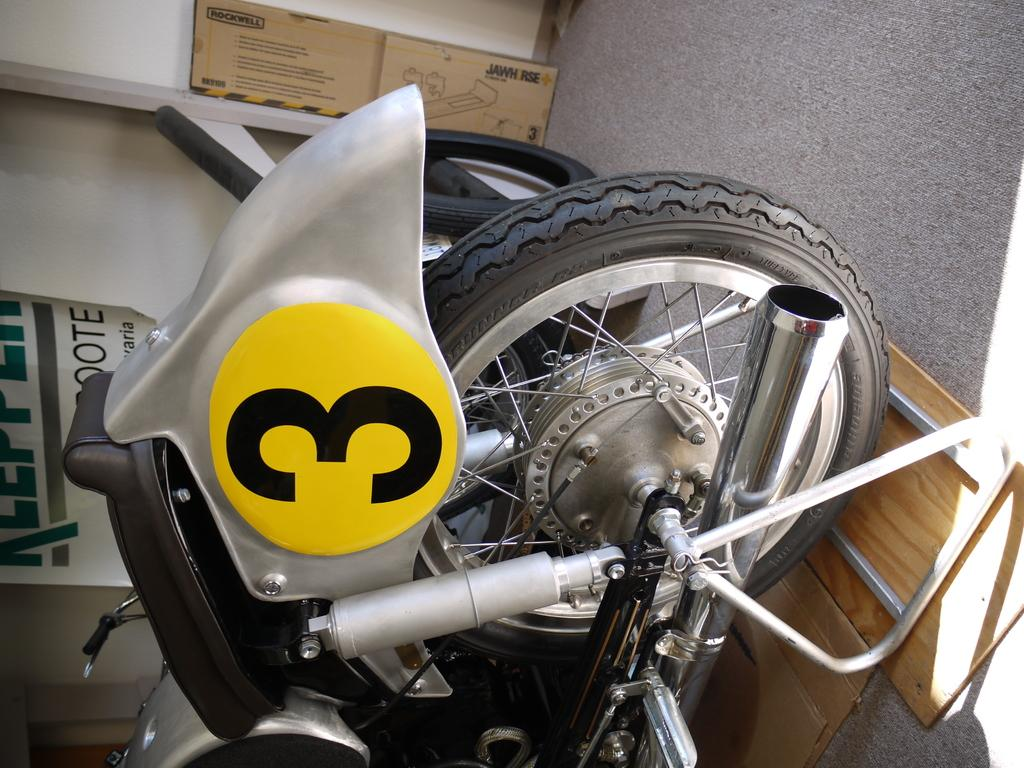<image>
Relay a brief, clear account of the picture shown. A large, yellow decal of the number 3 is placed on a motorcycle's fender. 